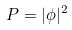<formula> <loc_0><loc_0><loc_500><loc_500>P = | \phi | ^ { 2 }</formula> 